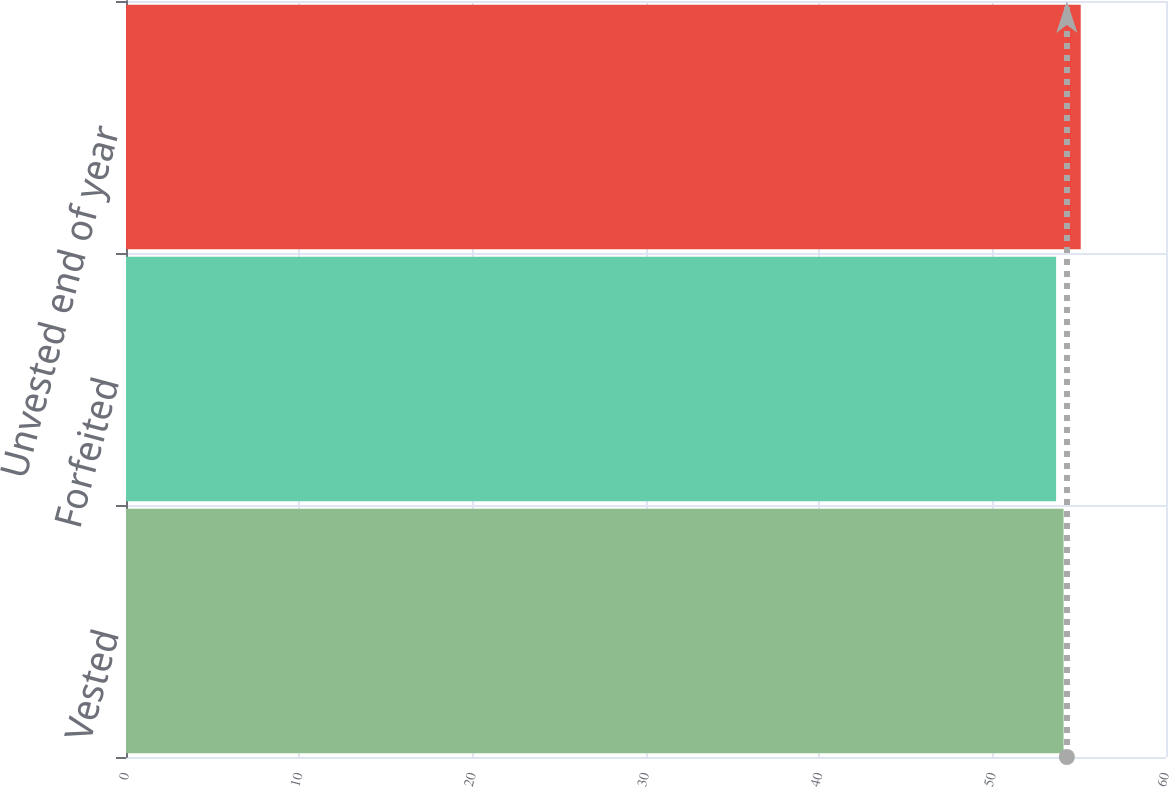Convert chart. <chart><loc_0><loc_0><loc_500><loc_500><bar_chart><fcel>Vested<fcel>Forfeited<fcel>Unvested end of year<nl><fcel>54.09<fcel>53.66<fcel>55.08<nl></chart> 